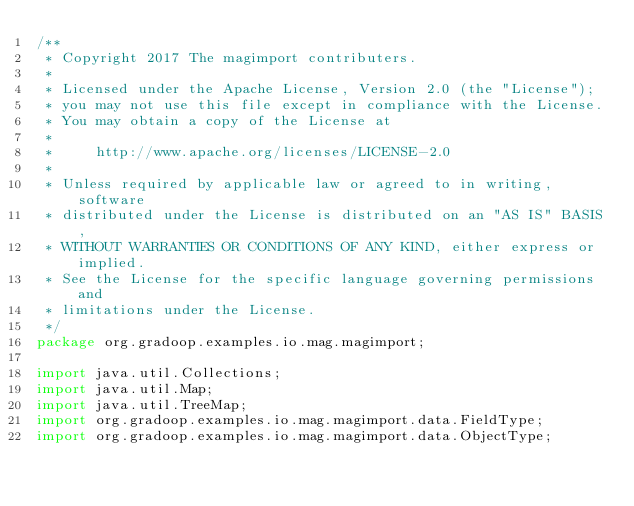Convert code to text. <code><loc_0><loc_0><loc_500><loc_500><_Java_>/**
 * Copyright 2017 The magimport contributers.
 *
 * Licensed under the Apache License, Version 2.0 (the "License");
 * you may not use this file except in compliance with the License.
 * You may obtain a copy of the License at
 *
 *     http://www.apache.org/licenses/LICENSE-2.0
 *
 * Unless required by applicable law or agreed to in writing, software
 * distributed under the License is distributed on an "AS IS" BASIS,
 * WITHOUT WARRANTIES OR CONDITIONS OF ANY KIND, either express or implied.
 * See the License for the specific language governing permissions and
 * limitations under the License.
 */
package org.gradoop.examples.io.mag.magimport;

import java.util.Collections;
import java.util.Map;
import java.util.TreeMap;
import org.gradoop.examples.io.mag.magimport.data.FieldType;
import org.gradoop.examples.io.mag.magimport.data.ObjectType;</code> 